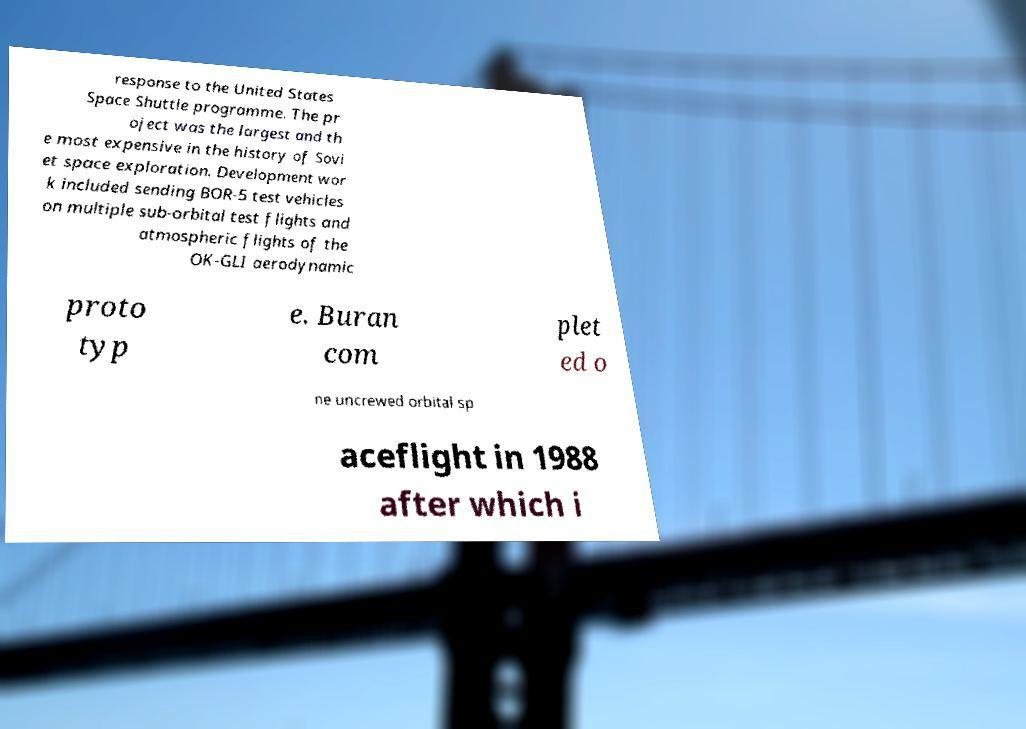Could you extract and type out the text from this image? response to the United States Space Shuttle programme. The pr oject was the largest and th e most expensive in the history of Sovi et space exploration. Development wor k included sending BOR-5 test vehicles on multiple sub-orbital test flights and atmospheric flights of the OK-GLI aerodynamic proto typ e. Buran com plet ed o ne uncrewed orbital sp aceflight in 1988 after which i 